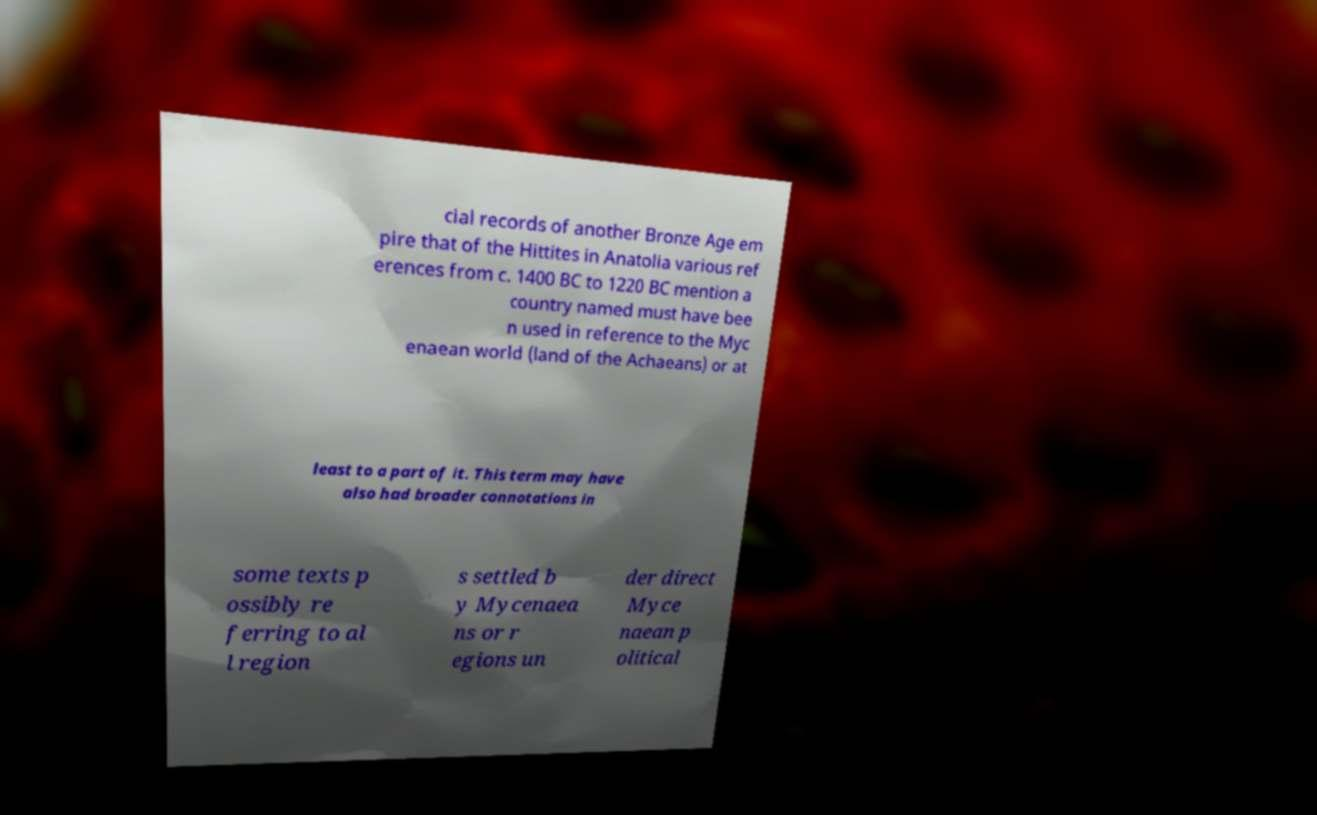Can you read and provide the text displayed in the image?This photo seems to have some interesting text. Can you extract and type it out for me? cial records of another Bronze Age em pire that of the Hittites in Anatolia various ref erences from c. 1400 BC to 1220 BC mention a country named must have bee n used in reference to the Myc enaean world (land of the Achaeans) or at least to a part of it. This term may have also had broader connotations in some texts p ossibly re ferring to al l region s settled b y Mycenaea ns or r egions un der direct Myce naean p olitical 